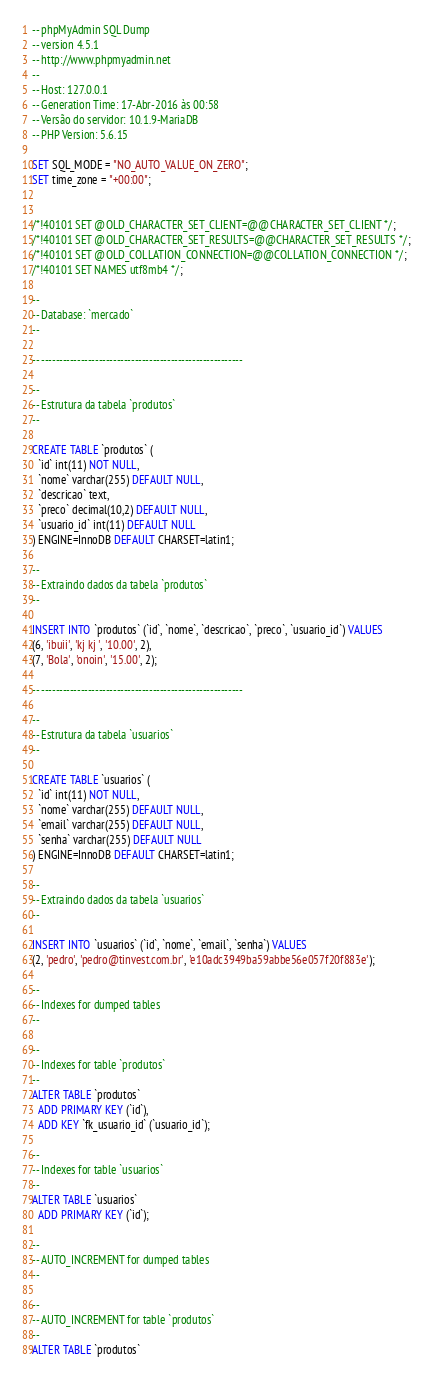<code> <loc_0><loc_0><loc_500><loc_500><_SQL_>-- phpMyAdmin SQL Dump
-- version 4.5.1
-- http://www.phpmyadmin.net
--
-- Host: 127.0.0.1
-- Generation Time: 17-Abr-2016 às 00:58
-- Versão do servidor: 10.1.9-MariaDB
-- PHP Version: 5.6.15

SET SQL_MODE = "NO_AUTO_VALUE_ON_ZERO";
SET time_zone = "+00:00";


/*!40101 SET @OLD_CHARACTER_SET_CLIENT=@@CHARACTER_SET_CLIENT */;
/*!40101 SET @OLD_CHARACTER_SET_RESULTS=@@CHARACTER_SET_RESULTS */;
/*!40101 SET @OLD_COLLATION_CONNECTION=@@COLLATION_CONNECTION */;
/*!40101 SET NAMES utf8mb4 */;

--
-- Database: `mercado`
--

-- --------------------------------------------------------

--
-- Estrutura da tabela `produtos`
--

CREATE TABLE `produtos` (
  `id` int(11) NOT NULL,
  `nome` varchar(255) DEFAULT NULL,
  `descricao` text,
  `preco` decimal(10,2) DEFAULT NULL,
  `usuario_id` int(11) DEFAULT NULL
) ENGINE=InnoDB DEFAULT CHARSET=latin1;

--
-- Extraindo dados da tabela `produtos`
--

INSERT INTO `produtos` (`id`, `nome`, `descricao`, `preco`, `usuario_id`) VALUES
(6, 'ibuii', 'kj kj ', '10.00', 2),
(7, 'Bola', 'onoin', '15.00', 2);

-- --------------------------------------------------------

--
-- Estrutura da tabela `usuarios`
--

CREATE TABLE `usuarios` (
  `id` int(11) NOT NULL,
  `nome` varchar(255) DEFAULT NULL,
  `email` varchar(255) DEFAULT NULL,
  `senha` varchar(255) DEFAULT NULL
) ENGINE=InnoDB DEFAULT CHARSET=latin1;

--
-- Extraindo dados da tabela `usuarios`
--

INSERT INTO `usuarios` (`id`, `nome`, `email`, `senha`) VALUES
(2, 'pedro', 'pedro@tinvest.com.br', 'e10adc3949ba59abbe56e057f20f883e');

--
-- Indexes for dumped tables
--

--
-- Indexes for table `produtos`
--
ALTER TABLE `produtos`
  ADD PRIMARY KEY (`id`),
  ADD KEY `fk_usuario_id` (`usuario_id`);

--
-- Indexes for table `usuarios`
--
ALTER TABLE `usuarios`
  ADD PRIMARY KEY (`id`);

--
-- AUTO_INCREMENT for dumped tables
--

--
-- AUTO_INCREMENT for table `produtos`
--
ALTER TABLE `produtos`</code> 